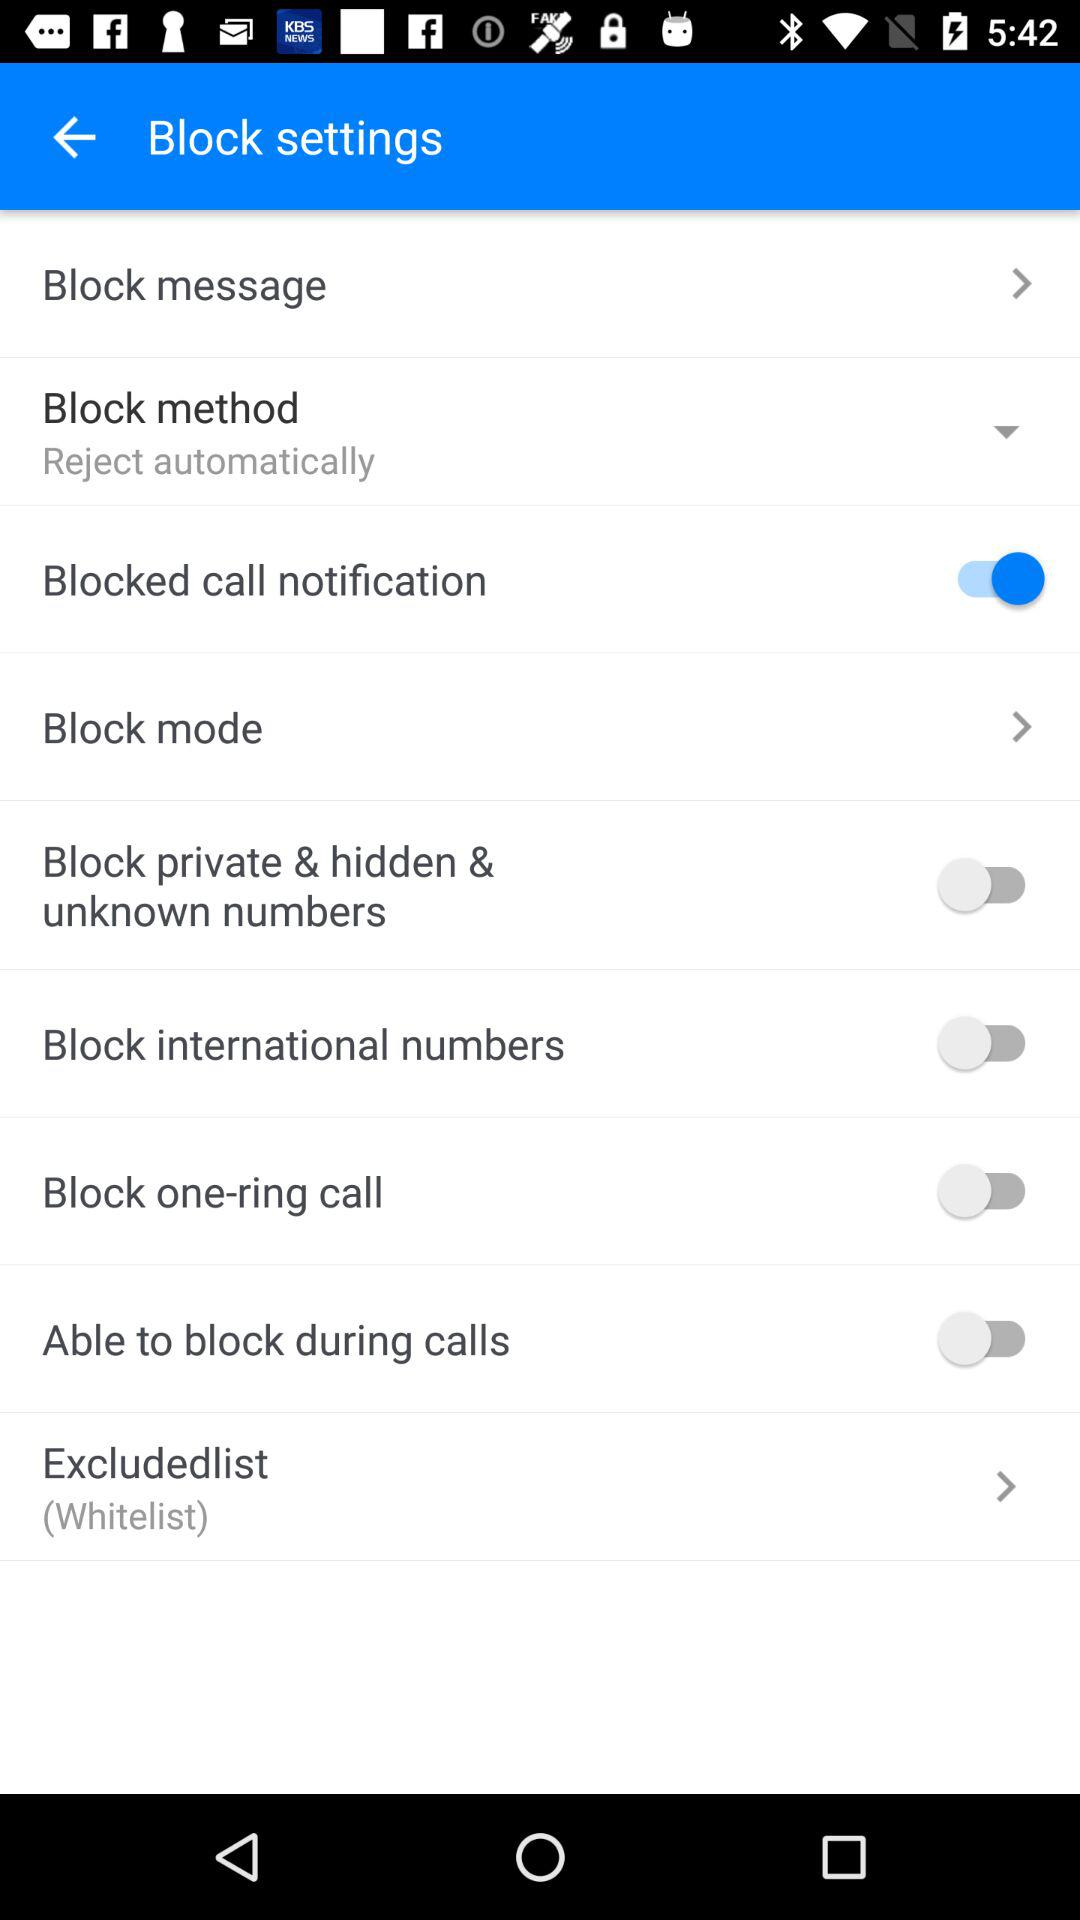What is the status of "Blocked call notification"? The status of "Blocked call notification" is "on". 